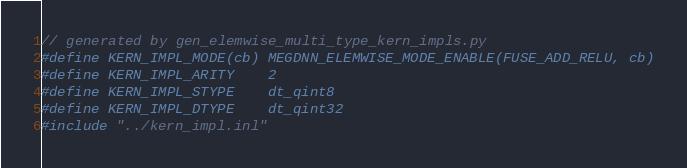Convert code to text. <code><loc_0><loc_0><loc_500><loc_500><_Cuda_>// generated by gen_elemwise_multi_type_kern_impls.py
#define KERN_IMPL_MODE(cb) MEGDNN_ELEMWISE_MODE_ENABLE(FUSE_ADD_RELU, cb)
#define KERN_IMPL_ARITY    2
#define KERN_IMPL_STYPE    dt_qint8
#define KERN_IMPL_DTYPE    dt_qint32
#include "../kern_impl.inl"
</code> 